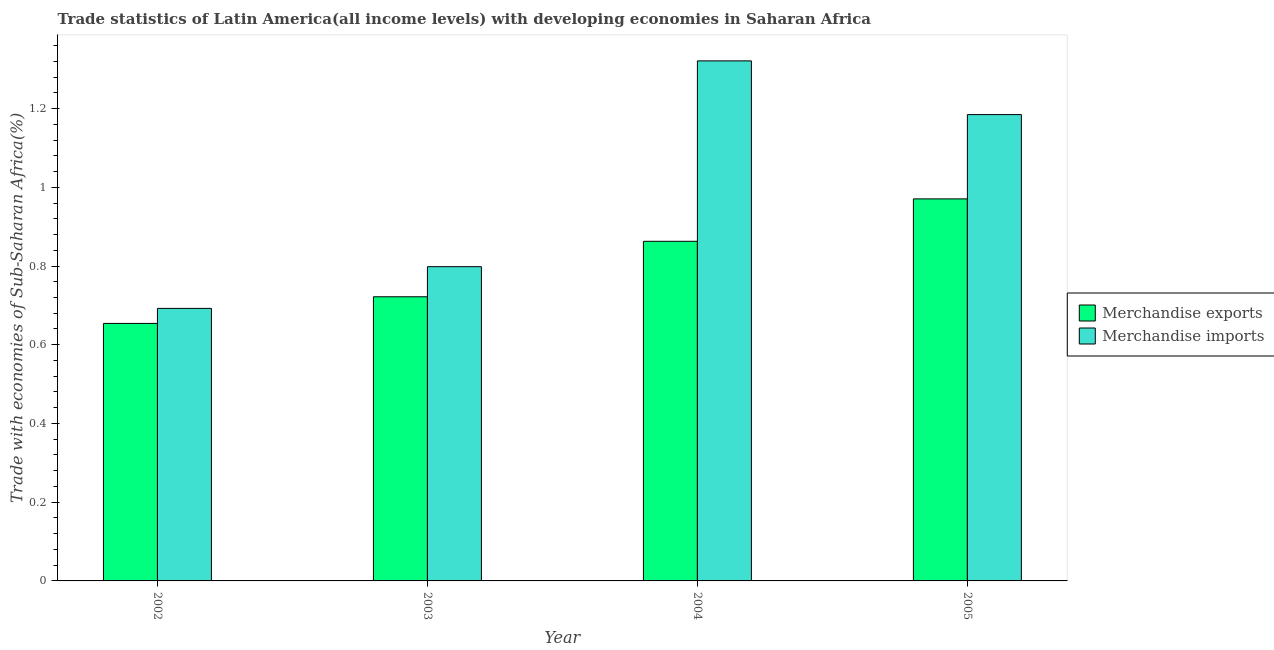How many different coloured bars are there?
Offer a terse response. 2. Are the number of bars per tick equal to the number of legend labels?
Your response must be concise. Yes. Are the number of bars on each tick of the X-axis equal?
Your response must be concise. Yes. How many bars are there on the 4th tick from the right?
Keep it short and to the point. 2. What is the label of the 3rd group of bars from the left?
Keep it short and to the point. 2004. What is the merchandise exports in 2004?
Offer a very short reply. 0.86. Across all years, what is the maximum merchandise imports?
Provide a short and direct response. 1.32. Across all years, what is the minimum merchandise exports?
Your answer should be very brief. 0.65. In which year was the merchandise imports maximum?
Give a very brief answer. 2004. In which year was the merchandise exports minimum?
Your answer should be very brief. 2002. What is the total merchandise imports in the graph?
Offer a terse response. 4. What is the difference between the merchandise exports in 2004 and that in 2005?
Give a very brief answer. -0.11. What is the difference between the merchandise imports in 2003 and the merchandise exports in 2004?
Ensure brevity in your answer.  -0.52. What is the average merchandise exports per year?
Give a very brief answer. 0.8. What is the ratio of the merchandise exports in 2002 to that in 2004?
Keep it short and to the point. 0.76. What is the difference between the highest and the second highest merchandise exports?
Ensure brevity in your answer.  0.11. What is the difference between the highest and the lowest merchandise exports?
Provide a succinct answer. 0.32. What does the 1st bar from the left in 2002 represents?
Offer a terse response. Merchandise exports. How many bars are there?
Your answer should be very brief. 8. How many years are there in the graph?
Your response must be concise. 4. What is the difference between two consecutive major ticks on the Y-axis?
Provide a succinct answer. 0.2. Does the graph contain grids?
Provide a succinct answer. No. Where does the legend appear in the graph?
Your answer should be very brief. Center right. How are the legend labels stacked?
Make the answer very short. Vertical. What is the title of the graph?
Offer a terse response. Trade statistics of Latin America(all income levels) with developing economies in Saharan Africa. What is the label or title of the X-axis?
Provide a short and direct response. Year. What is the label or title of the Y-axis?
Provide a short and direct response. Trade with economies of Sub-Saharan Africa(%). What is the Trade with economies of Sub-Saharan Africa(%) of Merchandise exports in 2002?
Your response must be concise. 0.65. What is the Trade with economies of Sub-Saharan Africa(%) in Merchandise imports in 2002?
Ensure brevity in your answer.  0.69. What is the Trade with economies of Sub-Saharan Africa(%) of Merchandise exports in 2003?
Your response must be concise. 0.72. What is the Trade with economies of Sub-Saharan Africa(%) in Merchandise imports in 2003?
Provide a succinct answer. 0.8. What is the Trade with economies of Sub-Saharan Africa(%) in Merchandise exports in 2004?
Ensure brevity in your answer.  0.86. What is the Trade with economies of Sub-Saharan Africa(%) in Merchandise imports in 2004?
Make the answer very short. 1.32. What is the Trade with economies of Sub-Saharan Africa(%) of Merchandise exports in 2005?
Offer a terse response. 0.97. What is the Trade with economies of Sub-Saharan Africa(%) of Merchandise imports in 2005?
Keep it short and to the point. 1.18. Across all years, what is the maximum Trade with economies of Sub-Saharan Africa(%) in Merchandise exports?
Your answer should be compact. 0.97. Across all years, what is the maximum Trade with economies of Sub-Saharan Africa(%) in Merchandise imports?
Offer a very short reply. 1.32. Across all years, what is the minimum Trade with economies of Sub-Saharan Africa(%) in Merchandise exports?
Your answer should be compact. 0.65. Across all years, what is the minimum Trade with economies of Sub-Saharan Africa(%) in Merchandise imports?
Make the answer very short. 0.69. What is the total Trade with economies of Sub-Saharan Africa(%) in Merchandise exports in the graph?
Offer a very short reply. 3.21. What is the total Trade with economies of Sub-Saharan Africa(%) in Merchandise imports in the graph?
Provide a succinct answer. 4. What is the difference between the Trade with economies of Sub-Saharan Africa(%) of Merchandise exports in 2002 and that in 2003?
Your answer should be very brief. -0.07. What is the difference between the Trade with economies of Sub-Saharan Africa(%) in Merchandise imports in 2002 and that in 2003?
Give a very brief answer. -0.11. What is the difference between the Trade with economies of Sub-Saharan Africa(%) of Merchandise exports in 2002 and that in 2004?
Give a very brief answer. -0.21. What is the difference between the Trade with economies of Sub-Saharan Africa(%) of Merchandise imports in 2002 and that in 2004?
Your response must be concise. -0.63. What is the difference between the Trade with economies of Sub-Saharan Africa(%) of Merchandise exports in 2002 and that in 2005?
Offer a very short reply. -0.32. What is the difference between the Trade with economies of Sub-Saharan Africa(%) in Merchandise imports in 2002 and that in 2005?
Give a very brief answer. -0.49. What is the difference between the Trade with economies of Sub-Saharan Africa(%) of Merchandise exports in 2003 and that in 2004?
Your answer should be compact. -0.14. What is the difference between the Trade with economies of Sub-Saharan Africa(%) in Merchandise imports in 2003 and that in 2004?
Give a very brief answer. -0.52. What is the difference between the Trade with economies of Sub-Saharan Africa(%) in Merchandise exports in 2003 and that in 2005?
Provide a succinct answer. -0.25. What is the difference between the Trade with economies of Sub-Saharan Africa(%) of Merchandise imports in 2003 and that in 2005?
Your answer should be very brief. -0.39. What is the difference between the Trade with economies of Sub-Saharan Africa(%) of Merchandise exports in 2004 and that in 2005?
Your answer should be compact. -0.11. What is the difference between the Trade with economies of Sub-Saharan Africa(%) of Merchandise imports in 2004 and that in 2005?
Ensure brevity in your answer.  0.14. What is the difference between the Trade with economies of Sub-Saharan Africa(%) of Merchandise exports in 2002 and the Trade with economies of Sub-Saharan Africa(%) of Merchandise imports in 2003?
Provide a short and direct response. -0.14. What is the difference between the Trade with economies of Sub-Saharan Africa(%) in Merchandise exports in 2002 and the Trade with economies of Sub-Saharan Africa(%) in Merchandise imports in 2004?
Ensure brevity in your answer.  -0.67. What is the difference between the Trade with economies of Sub-Saharan Africa(%) in Merchandise exports in 2002 and the Trade with economies of Sub-Saharan Africa(%) in Merchandise imports in 2005?
Provide a succinct answer. -0.53. What is the difference between the Trade with economies of Sub-Saharan Africa(%) of Merchandise exports in 2003 and the Trade with economies of Sub-Saharan Africa(%) of Merchandise imports in 2004?
Your answer should be very brief. -0.6. What is the difference between the Trade with economies of Sub-Saharan Africa(%) of Merchandise exports in 2003 and the Trade with economies of Sub-Saharan Africa(%) of Merchandise imports in 2005?
Your response must be concise. -0.46. What is the difference between the Trade with economies of Sub-Saharan Africa(%) of Merchandise exports in 2004 and the Trade with economies of Sub-Saharan Africa(%) of Merchandise imports in 2005?
Your answer should be very brief. -0.32. What is the average Trade with economies of Sub-Saharan Africa(%) of Merchandise exports per year?
Make the answer very short. 0.8. In the year 2002, what is the difference between the Trade with economies of Sub-Saharan Africa(%) of Merchandise exports and Trade with economies of Sub-Saharan Africa(%) of Merchandise imports?
Keep it short and to the point. -0.04. In the year 2003, what is the difference between the Trade with economies of Sub-Saharan Africa(%) in Merchandise exports and Trade with economies of Sub-Saharan Africa(%) in Merchandise imports?
Provide a succinct answer. -0.08. In the year 2004, what is the difference between the Trade with economies of Sub-Saharan Africa(%) in Merchandise exports and Trade with economies of Sub-Saharan Africa(%) in Merchandise imports?
Provide a succinct answer. -0.46. In the year 2005, what is the difference between the Trade with economies of Sub-Saharan Africa(%) of Merchandise exports and Trade with economies of Sub-Saharan Africa(%) of Merchandise imports?
Provide a succinct answer. -0.21. What is the ratio of the Trade with economies of Sub-Saharan Africa(%) of Merchandise exports in 2002 to that in 2003?
Give a very brief answer. 0.91. What is the ratio of the Trade with economies of Sub-Saharan Africa(%) of Merchandise imports in 2002 to that in 2003?
Give a very brief answer. 0.87. What is the ratio of the Trade with economies of Sub-Saharan Africa(%) of Merchandise exports in 2002 to that in 2004?
Make the answer very short. 0.76. What is the ratio of the Trade with economies of Sub-Saharan Africa(%) in Merchandise imports in 2002 to that in 2004?
Provide a succinct answer. 0.52. What is the ratio of the Trade with economies of Sub-Saharan Africa(%) of Merchandise exports in 2002 to that in 2005?
Give a very brief answer. 0.67. What is the ratio of the Trade with economies of Sub-Saharan Africa(%) in Merchandise imports in 2002 to that in 2005?
Your answer should be compact. 0.58. What is the ratio of the Trade with economies of Sub-Saharan Africa(%) of Merchandise exports in 2003 to that in 2004?
Ensure brevity in your answer.  0.84. What is the ratio of the Trade with economies of Sub-Saharan Africa(%) in Merchandise imports in 2003 to that in 2004?
Give a very brief answer. 0.6. What is the ratio of the Trade with economies of Sub-Saharan Africa(%) in Merchandise exports in 2003 to that in 2005?
Your answer should be very brief. 0.74. What is the ratio of the Trade with economies of Sub-Saharan Africa(%) of Merchandise imports in 2003 to that in 2005?
Make the answer very short. 0.67. What is the ratio of the Trade with economies of Sub-Saharan Africa(%) in Merchandise exports in 2004 to that in 2005?
Your answer should be very brief. 0.89. What is the ratio of the Trade with economies of Sub-Saharan Africa(%) of Merchandise imports in 2004 to that in 2005?
Ensure brevity in your answer.  1.12. What is the difference between the highest and the second highest Trade with economies of Sub-Saharan Africa(%) of Merchandise exports?
Your answer should be very brief. 0.11. What is the difference between the highest and the second highest Trade with economies of Sub-Saharan Africa(%) of Merchandise imports?
Make the answer very short. 0.14. What is the difference between the highest and the lowest Trade with economies of Sub-Saharan Africa(%) of Merchandise exports?
Give a very brief answer. 0.32. What is the difference between the highest and the lowest Trade with economies of Sub-Saharan Africa(%) in Merchandise imports?
Your response must be concise. 0.63. 